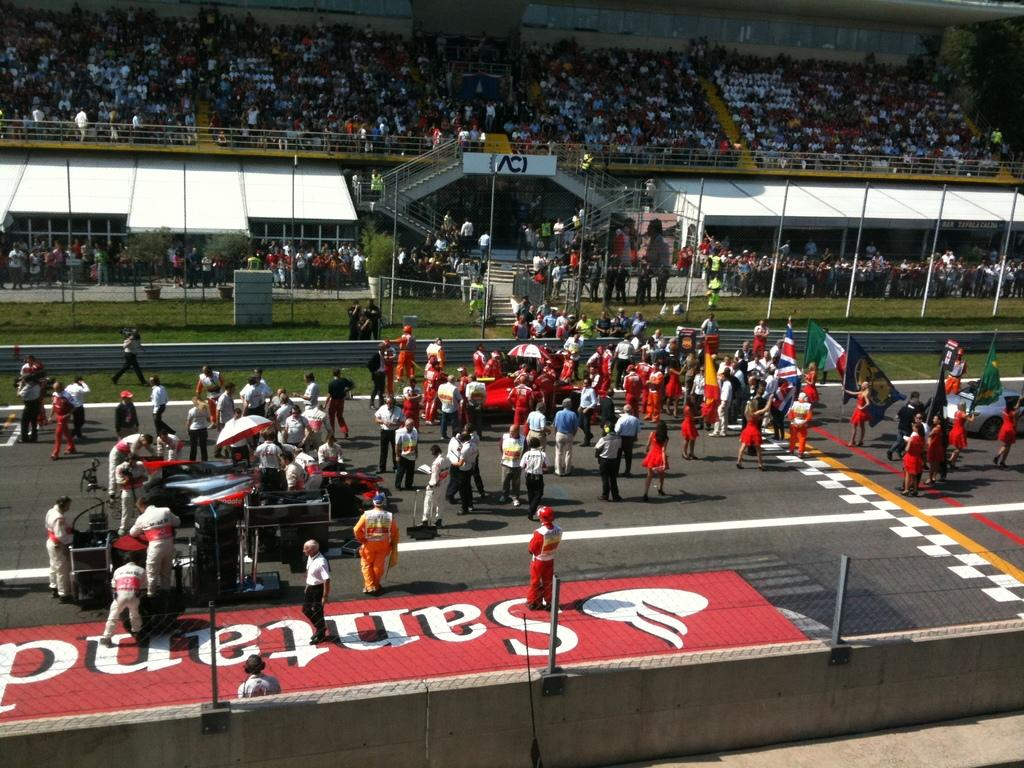<image>
Summarize the visual content of the image. A crowd of people are standing on a race track and the stadium archway says ACI. 